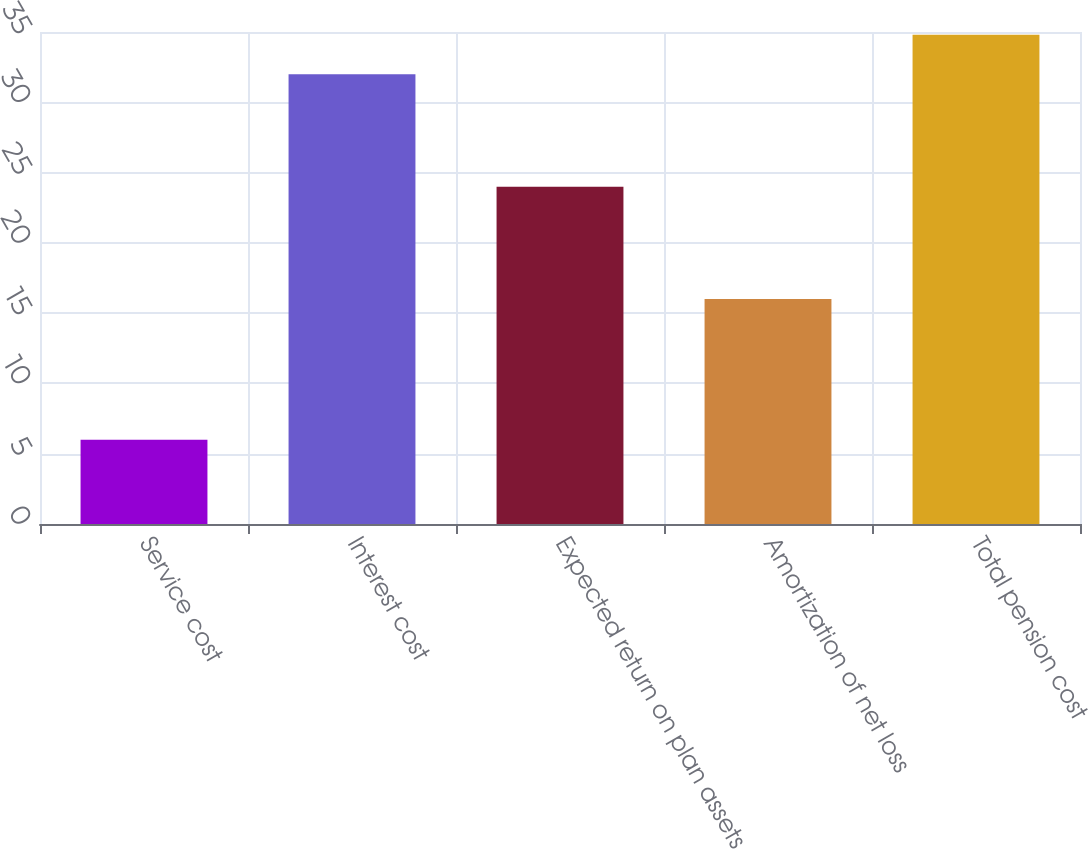<chart> <loc_0><loc_0><loc_500><loc_500><bar_chart><fcel>Service cost<fcel>Interest cost<fcel>Expected return on plan assets<fcel>Amortization of net loss<fcel>Total pension cost<nl><fcel>6<fcel>32<fcel>24<fcel>16<fcel>34.8<nl></chart> 